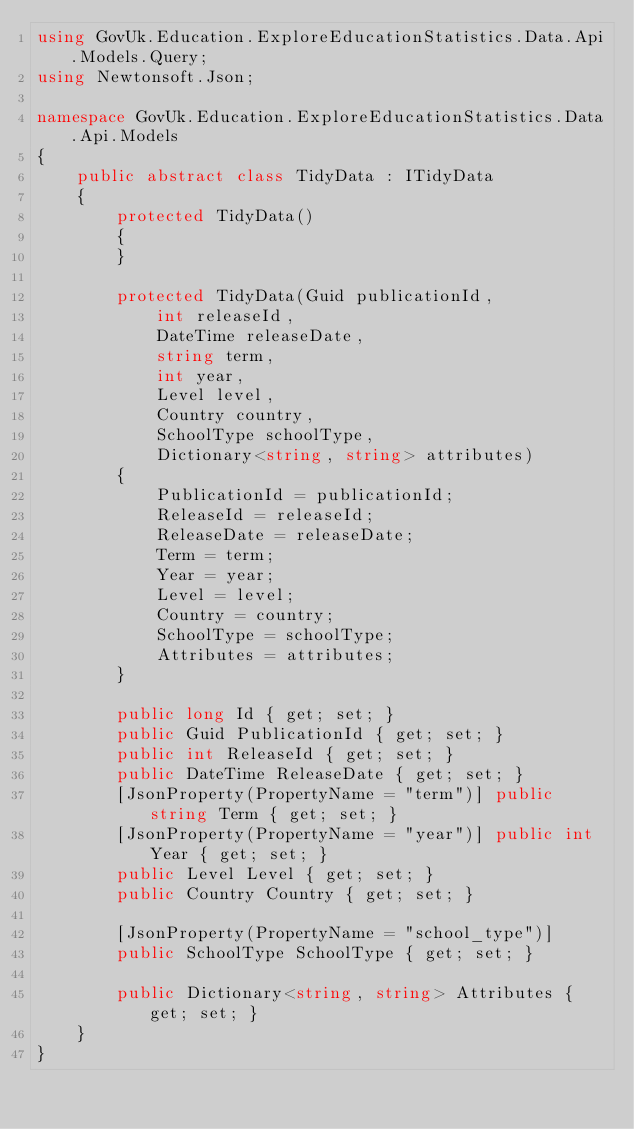Convert code to text. <code><loc_0><loc_0><loc_500><loc_500><_C#_>using GovUk.Education.ExploreEducationStatistics.Data.Api.Models.Query;
using Newtonsoft.Json;

namespace GovUk.Education.ExploreEducationStatistics.Data.Api.Models
{
    public abstract class TidyData : ITidyData
    {
        protected TidyData()
        {
        }

        protected TidyData(Guid publicationId,
            int releaseId,
            DateTime releaseDate,
            string term,
            int year,
            Level level,
            Country country,
            SchoolType schoolType,
            Dictionary<string, string> attributes)
        {
            PublicationId = publicationId;
            ReleaseId = releaseId;
            ReleaseDate = releaseDate;
            Term = term;
            Year = year;
            Level = level;
            Country = country;
            SchoolType = schoolType;
            Attributes = attributes;
        }

        public long Id { get; set; }
        public Guid PublicationId { get; set; }
        public int ReleaseId { get; set; }
        public DateTime ReleaseDate { get; set; }
        [JsonProperty(PropertyName = "term")] public string Term { get; set; }
        [JsonProperty(PropertyName = "year")] public int Year { get; set; }
        public Level Level { get; set; }
        public Country Country { get; set; }

        [JsonProperty(PropertyName = "school_type")]
        public SchoolType SchoolType { get; set; }

        public Dictionary<string, string> Attributes { get; set; }
    }
}</code> 